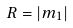<formula> <loc_0><loc_0><loc_500><loc_500>R = | m _ { 1 } |</formula> 